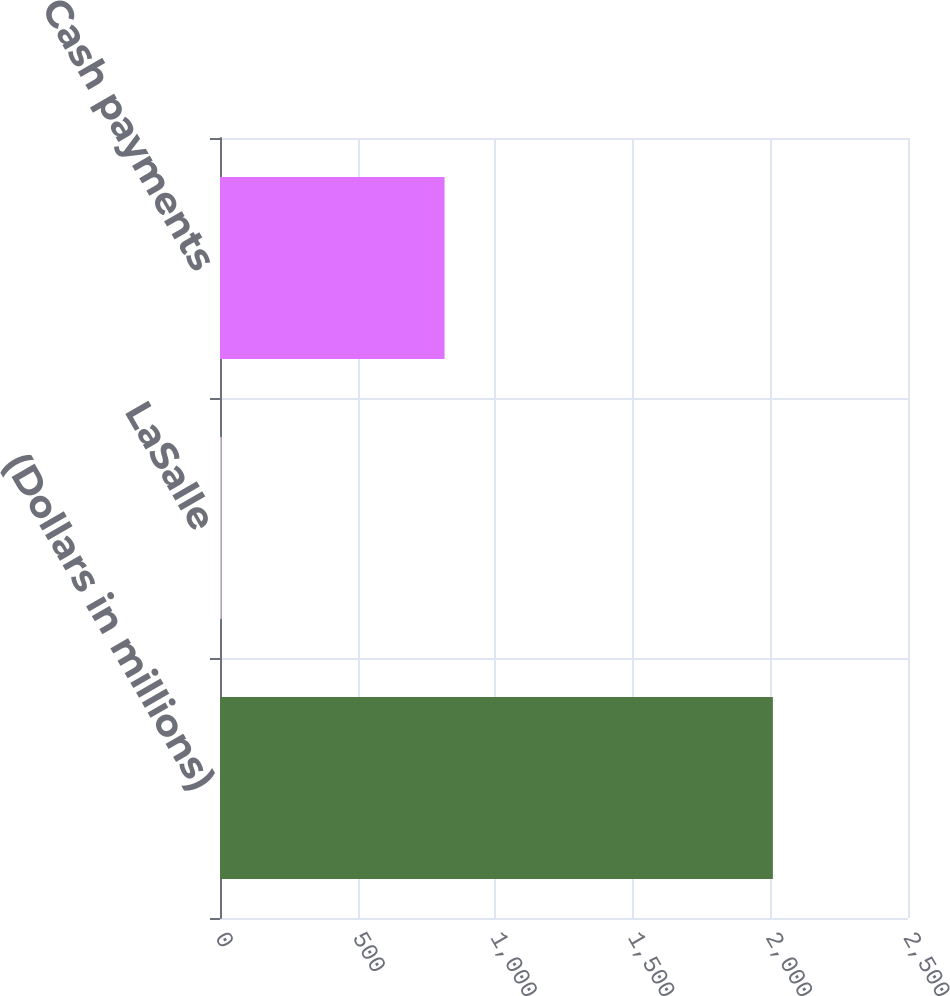Convert chart. <chart><loc_0><loc_0><loc_500><loc_500><bar_chart><fcel>(Dollars in millions)<fcel>LaSalle<fcel>Cash payments<nl><fcel>2009<fcel>6<fcel>816<nl></chart> 